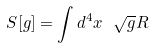Convert formula to latex. <formula><loc_0><loc_0><loc_500><loc_500>S [ g ] = \int d ^ { 4 } x \ \sqrt { g } R</formula> 